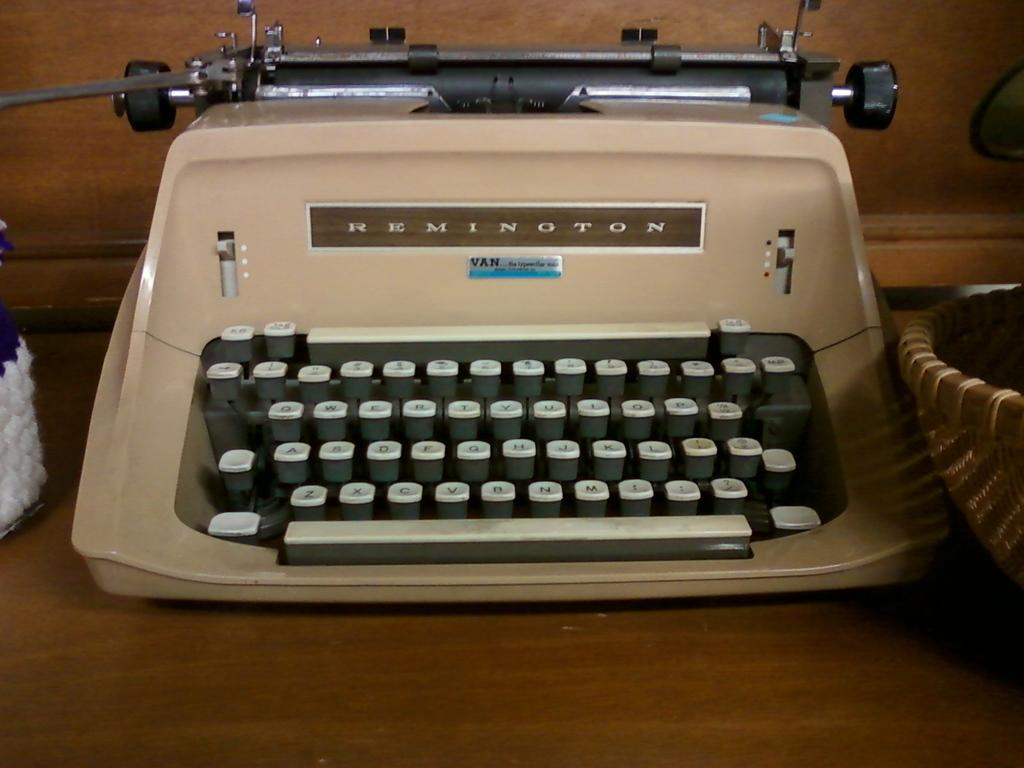What piece of furniture is present in the image? There is a table in the image. What object is placed on the table? There is a typing machine on the table. Can you describe any other objects near the typing machine? There may be a basket beside the typing machine. What can be seen in the background of the image? There is a wall visible in the image. What type of railway is visible in the image? There is no railway present in the image. How many businesses can be seen in the image? There is no indication of a business in the image. 